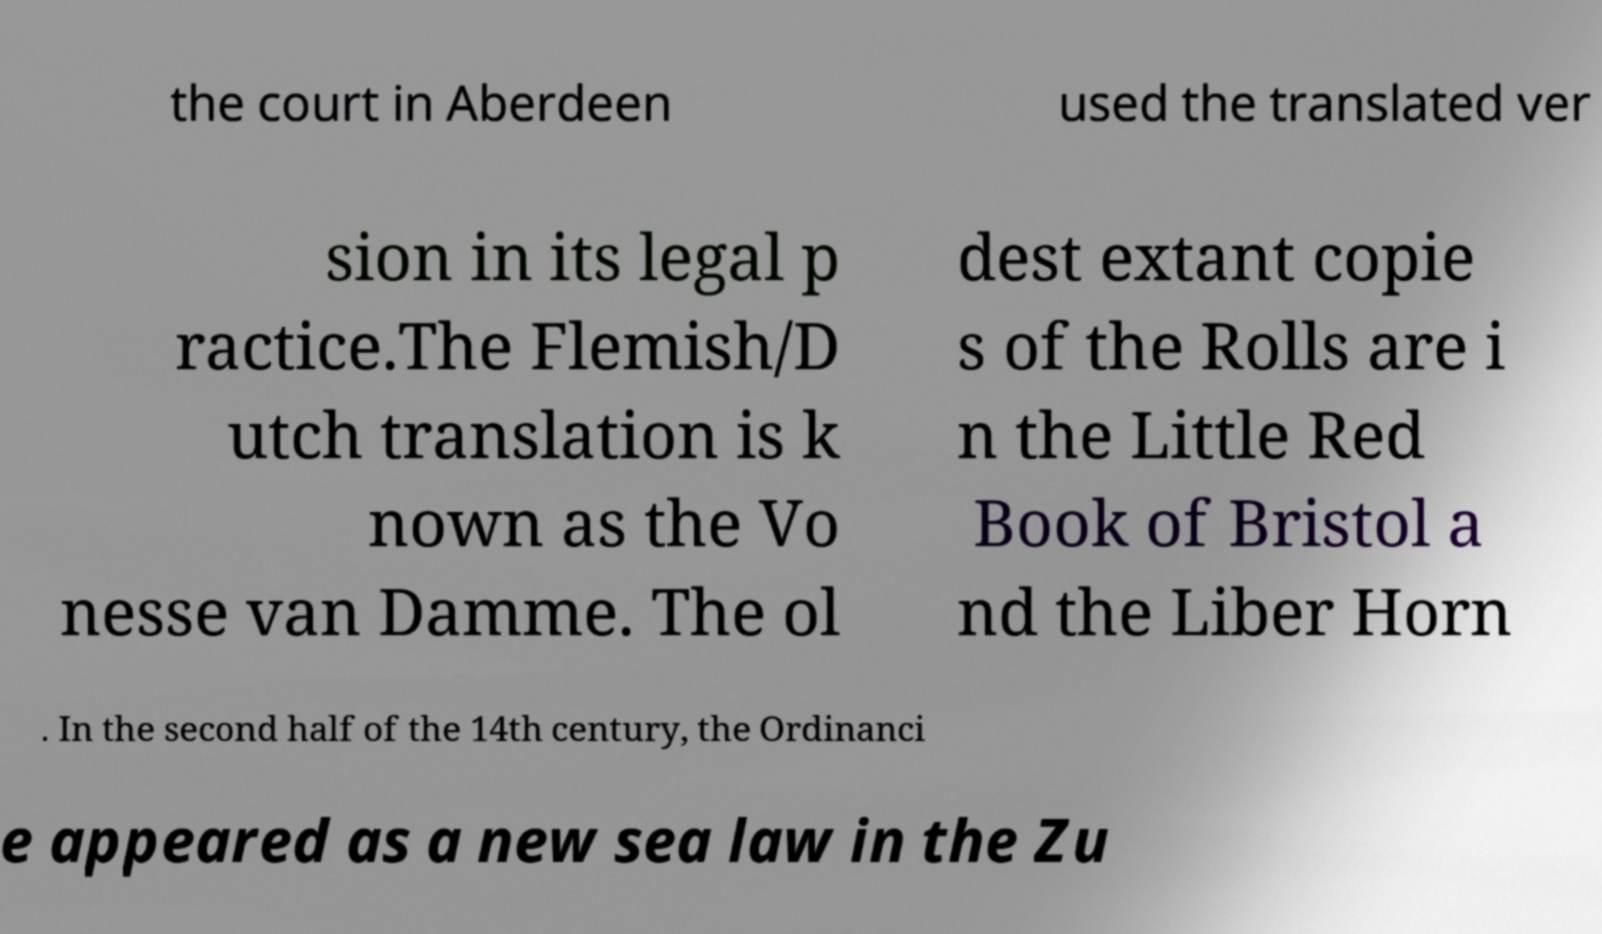I need the written content from this picture converted into text. Can you do that? the court in Aberdeen used the translated ver sion in its legal p ractice.The Flemish/D utch translation is k nown as the Vo nesse van Damme. The ol dest extant copie s of the Rolls are i n the Little Red Book of Bristol a nd the Liber Horn . In the second half of the 14th century, the Ordinanci e appeared as a new sea law in the Zu 